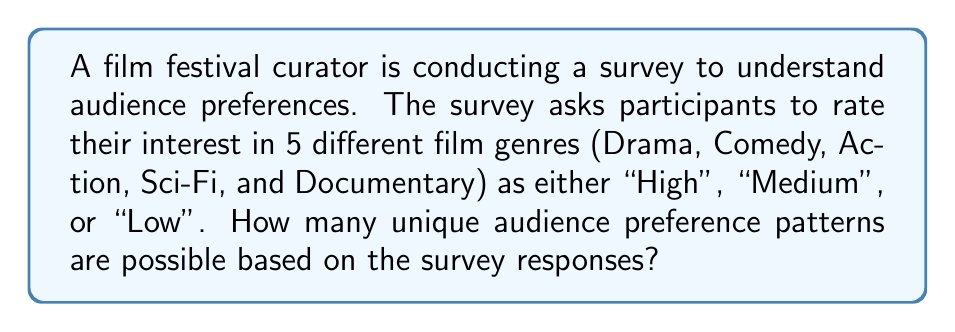Help me with this question. Let's approach this step-by-step:

1) For each film genre, there are 3 possible responses: High, Medium, or Low.

2) We need to determine how many ways we can choose one response for each of the 5 genres.

3) This is a perfect scenario for applying the multiplication principle in combinatorics.

4) For each genre, we have 3 choices, and we're making this choice 5 times (once for each genre).

5) Therefore, the total number of unique patterns is:

   $$3 \times 3 \times 3 \times 3 \times 3 = 3^5$$

6) Let's calculate this:
   $$3^5 = 3 \times 3 \times 3 \times 3 \times 3 = 243$$

Thus, there are 243 unique audience preference patterns possible based on the survey responses.
Answer: $3^5 = 243$ 